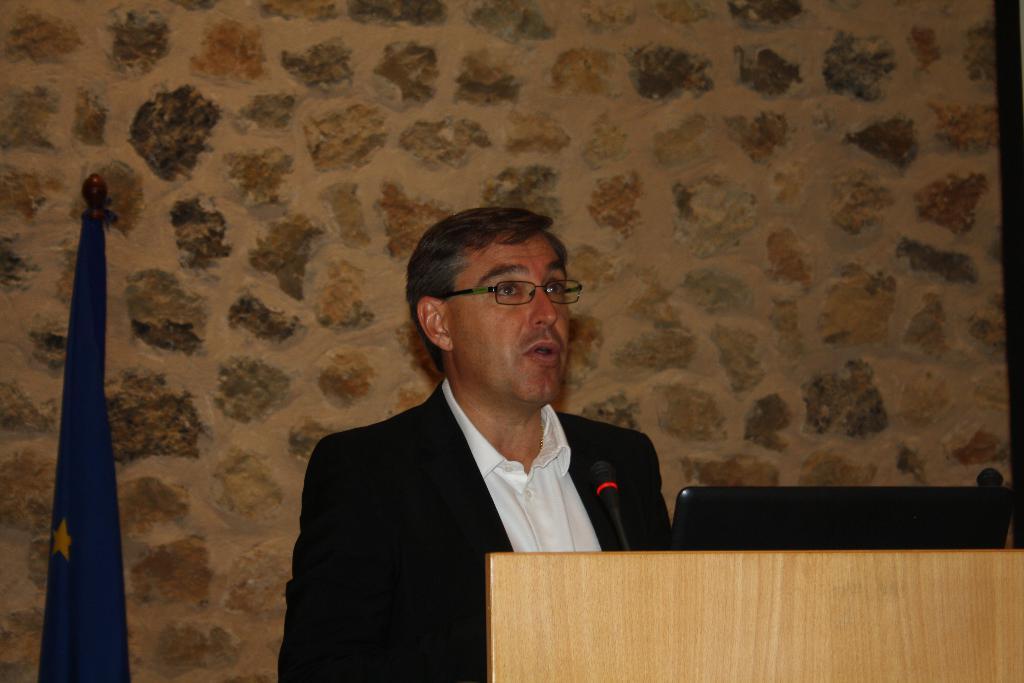In one or two sentences, can you explain what this image depicts? In this image, we can see a person wearing glasses and we can see a mic and a laptop on the podium. In the background, there is a flag and we can see a wall. 